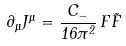Convert formula to latex. <formula><loc_0><loc_0><loc_500><loc_500>\partial _ { \mu } J ^ { \mu } = \frac { C _ { - } } { 1 6 \pi ^ { 2 } } \, F \tilde { F }</formula> 